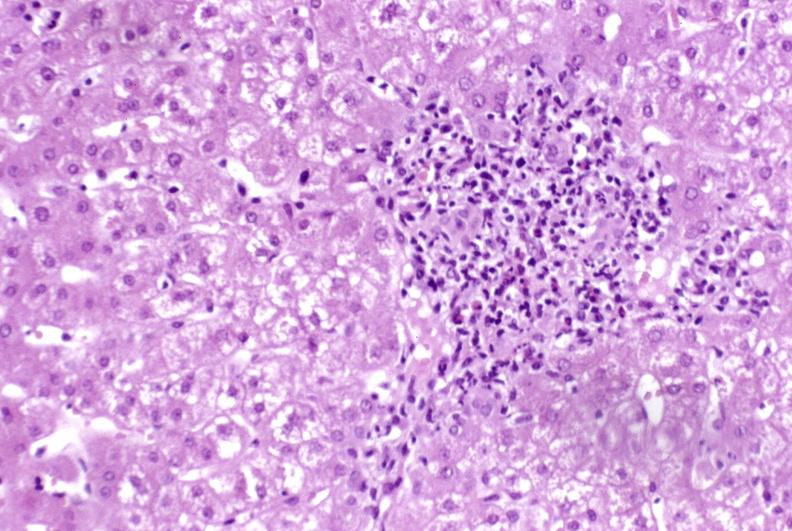what is present?
Answer the question using a single word or phrase. Hepatobiliary 